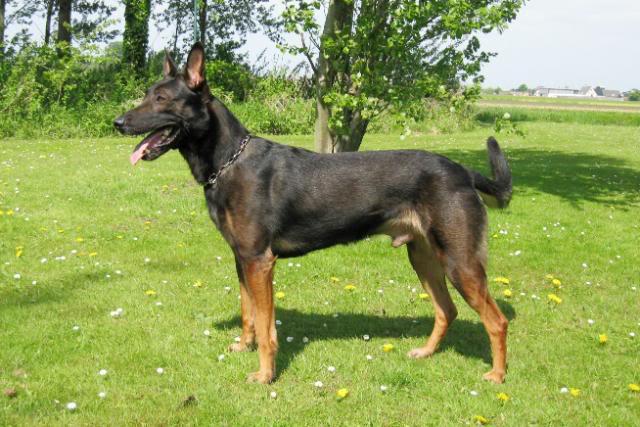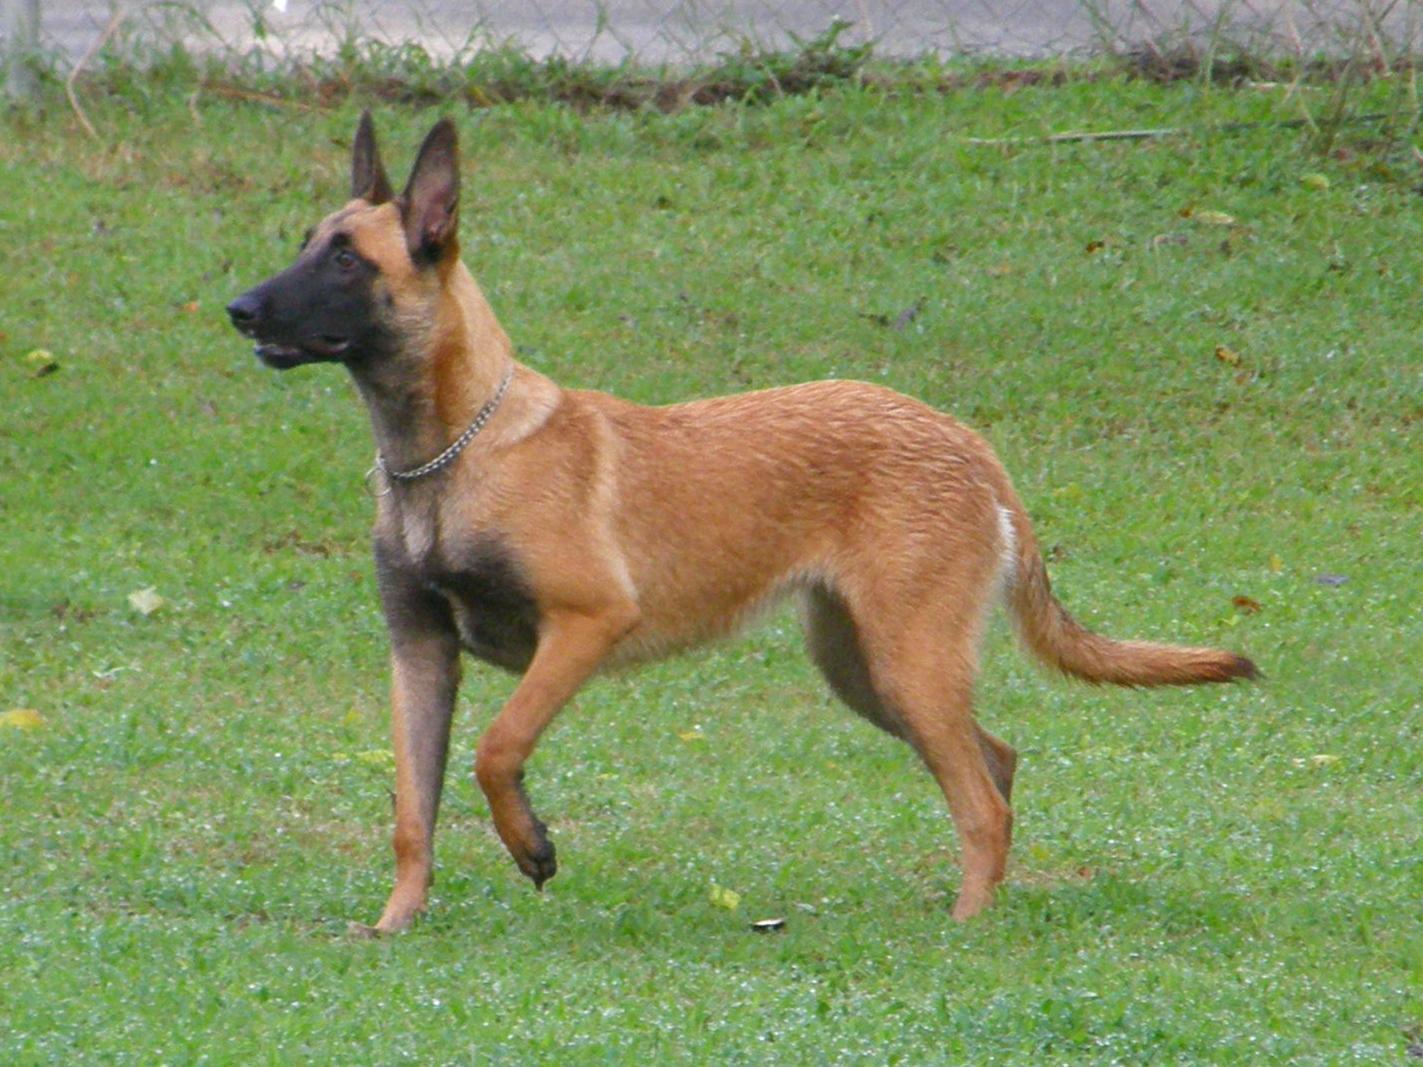The first image is the image on the left, the second image is the image on the right. Considering the images on both sides, is "At least one dog has a leash attached, and at least one dog has an open, non-snarling mouth." valid? Answer yes or no. No. The first image is the image on the left, the second image is the image on the right. Considering the images on both sides, is "One of the dogs is sitting down & looking towards the camera." valid? Answer yes or no. No. 